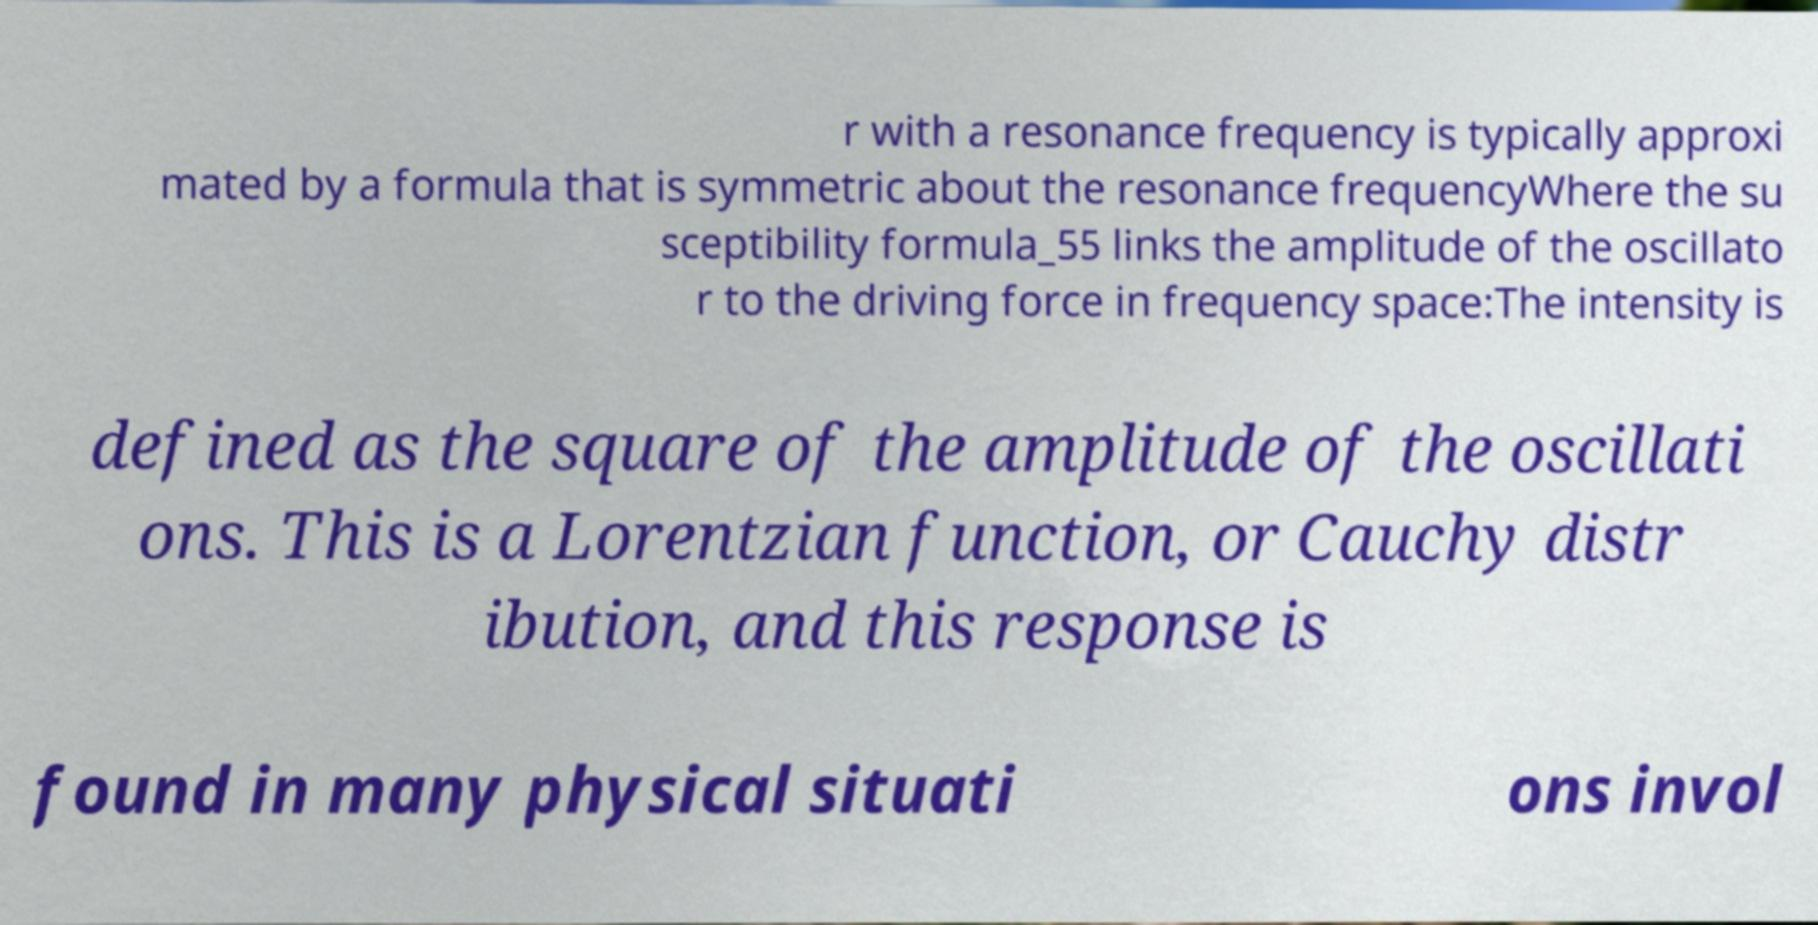For documentation purposes, I need the text within this image transcribed. Could you provide that? r with a resonance frequency is typically approxi mated by a formula that is symmetric about the resonance frequencyWhere the su sceptibility formula_55 links the amplitude of the oscillato r to the driving force in frequency space:The intensity is defined as the square of the amplitude of the oscillati ons. This is a Lorentzian function, or Cauchy distr ibution, and this response is found in many physical situati ons invol 